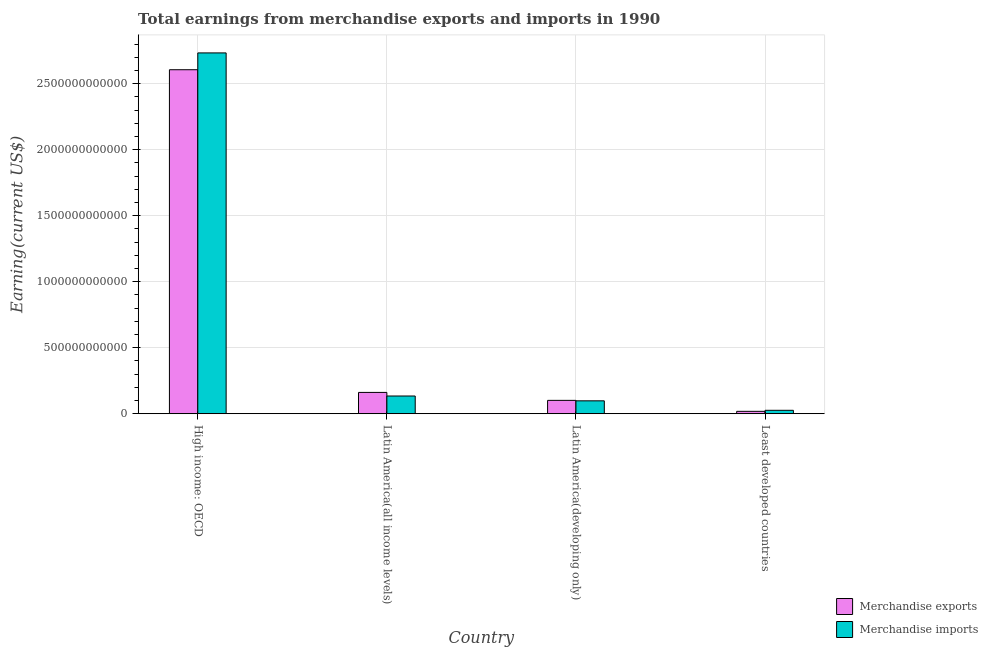How many groups of bars are there?
Make the answer very short. 4. Are the number of bars on each tick of the X-axis equal?
Make the answer very short. Yes. How many bars are there on the 2nd tick from the left?
Provide a succinct answer. 2. How many bars are there on the 4th tick from the right?
Provide a short and direct response. 2. What is the label of the 4th group of bars from the left?
Ensure brevity in your answer.  Least developed countries. What is the earnings from merchandise exports in Latin America(all income levels)?
Make the answer very short. 1.61e+11. Across all countries, what is the maximum earnings from merchandise imports?
Your response must be concise. 2.73e+12. Across all countries, what is the minimum earnings from merchandise imports?
Make the answer very short. 2.60e+1. In which country was the earnings from merchandise exports maximum?
Ensure brevity in your answer.  High income: OECD. In which country was the earnings from merchandise exports minimum?
Offer a very short reply. Least developed countries. What is the total earnings from merchandise exports in the graph?
Give a very brief answer. 2.89e+12. What is the difference between the earnings from merchandise exports in Latin America(developing only) and that in Least developed countries?
Keep it short and to the point. 8.30e+1. What is the difference between the earnings from merchandise imports in Latin America(all income levels) and the earnings from merchandise exports in High income: OECD?
Make the answer very short. -2.47e+12. What is the average earnings from merchandise exports per country?
Keep it short and to the point. 7.22e+11. What is the difference between the earnings from merchandise exports and earnings from merchandise imports in Latin America(developing only)?
Ensure brevity in your answer.  3.56e+09. In how many countries, is the earnings from merchandise exports greater than 2000000000000 US$?
Make the answer very short. 1. What is the ratio of the earnings from merchandise exports in Latin America(developing only) to that in Least developed countries?
Your response must be concise. 5.55. Is the earnings from merchandise imports in Latin America(all income levels) less than that in Least developed countries?
Make the answer very short. No. Is the difference between the earnings from merchandise exports in Latin America(all income levels) and Least developed countries greater than the difference between the earnings from merchandise imports in Latin America(all income levels) and Least developed countries?
Ensure brevity in your answer.  Yes. What is the difference between the highest and the second highest earnings from merchandise imports?
Give a very brief answer. 2.60e+12. What is the difference between the highest and the lowest earnings from merchandise exports?
Offer a terse response. 2.59e+12. What does the 2nd bar from the left in High income: OECD represents?
Make the answer very short. Merchandise imports. How many bars are there?
Keep it short and to the point. 8. What is the difference between two consecutive major ticks on the Y-axis?
Give a very brief answer. 5.00e+11. Are the values on the major ticks of Y-axis written in scientific E-notation?
Keep it short and to the point. No. Where does the legend appear in the graph?
Your answer should be very brief. Bottom right. How many legend labels are there?
Your answer should be very brief. 2. What is the title of the graph?
Provide a succinct answer. Total earnings from merchandise exports and imports in 1990. Does "Secondary school" appear as one of the legend labels in the graph?
Your response must be concise. No. What is the label or title of the Y-axis?
Your response must be concise. Earning(current US$). What is the Earning(current US$) in Merchandise exports in High income: OECD?
Your response must be concise. 2.61e+12. What is the Earning(current US$) of Merchandise imports in High income: OECD?
Keep it short and to the point. 2.73e+12. What is the Earning(current US$) of Merchandise exports in Latin America(all income levels)?
Your response must be concise. 1.61e+11. What is the Earning(current US$) of Merchandise imports in Latin America(all income levels)?
Give a very brief answer. 1.34e+11. What is the Earning(current US$) in Merchandise exports in Latin America(developing only)?
Make the answer very short. 1.01e+11. What is the Earning(current US$) of Merchandise imports in Latin America(developing only)?
Offer a very short reply. 9.77e+1. What is the Earning(current US$) of Merchandise exports in Least developed countries?
Ensure brevity in your answer.  1.82e+1. What is the Earning(current US$) of Merchandise imports in Least developed countries?
Your answer should be very brief. 2.60e+1. Across all countries, what is the maximum Earning(current US$) of Merchandise exports?
Offer a terse response. 2.61e+12. Across all countries, what is the maximum Earning(current US$) in Merchandise imports?
Keep it short and to the point. 2.73e+12. Across all countries, what is the minimum Earning(current US$) in Merchandise exports?
Your response must be concise. 1.82e+1. Across all countries, what is the minimum Earning(current US$) in Merchandise imports?
Provide a short and direct response. 2.60e+1. What is the total Earning(current US$) in Merchandise exports in the graph?
Your answer should be compact. 2.89e+12. What is the total Earning(current US$) in Merchandise imports in the graph?
Provide a succinct answer. 2.99e+12. What is the difference between the Earning(current US$) in Merchandise exports in High income: OECD and that in Latin America(all income levels)?
Offer a terse response. 2.44e+12. What is the difference between the Earning(current US$) of Merchandise imports in High income: OECD and that in Latin America(all income levels)?
Keep it short and to the point. 2.60e+12. What is the difference between the Earning(current US$) in Merchandise exports in High income: OECD and that in Latin America(developing only)?
Provide a short and direct response. 2.50e+12. What is the difference between the Earning(current US$) of Merchandise imports in High income: OECD and that in Latin America(developing only)?
Your answer should be very brief. 2.64e+12. What is the difference between the Earning(current US$) of Merchandise exports in High income: OECD and that in Least developed countries?
Give a very brief answer. 2.59e+12. What is the difference between the Earning(current US$) of Merchandise imports in High income: OECD and that in Least developed countries?
Provide a succinct answer. 2.71e+12. What is the difference between the Earning(current US$) of Merchandise exports in Latin America(all income levels) and that in Latin America(developing only)?
Your answer should be very brief. 6.02e+1. What is the difference between the Earning(current US$) in Merchandise imports in Latin America(all income levels) and that in Latin America(developing only)?
Keep it short and to the point. 3.65e+1. What is the difference between the Earning(current US$) of Merchandise exports in Latin America(all income levels) and that in Least developed countries?
Make the answer very short. 1.43e+11. What is the difference between the Earning(current US$) of Merchandise imports in Latin America(all income levels) and that in Least developed countries?
Provide a short and direct response. 1.08e+11. What is the difference between the Earning(current US$) in Merchandise exports in Latin America(developing only) and that in Least developed countries?
Your answer should be compact. 8.30e+1. What is the difference between the Earning(current US$) in Merchandise imports in Latin America(developing only) and that in Least developed countries?
Your answer should be compact. 7.17e+1. What is the difference between the Earning(current US$) in Merchandise exports in High income: OECD and the Earning(current US$) in Merchandise imports in Latin America(all income levels)?
Provide a succinct answer. 2.47e+12. What is the difference between the Earning(current US$) of Merchandise exports in High income: OECD and the Earning(current US$) of Merchandise imports in Latin America(developing only)?
Keep it short and to the point. 2.51e+12. What is the difference between the Earning(current US$) of Merchandise exports in High income: OECD and the Earning(current US$) of Merchandise imports in Least developed countries?
Make the answer very short. 2.58e+12. What is the difference between the Earning(current US$) of Merchandise exports in Latin America(all income levels) and the Earning(current US$) of Merchandise imports in Latin America(developing only)?
Give a very brief answer. 6.38e+1. What is the difference between the Earning(current US$) of Merchandise exports in Latin America(all income levels) and the Earning(current US$) of Merchandise imports in Least developed countries?
Offer a very short reply. 1.35e+11. What is the difference between the Earning(current US$) in Merchandise exports in Latin America(developing only) and the Earning(current US$) in Merchandise imports in Least developed countries?
Your answer should be compact. 7.53e+1. What is the average Earning(current US$) in Merchandise exports per country?
Your response must be concise. 7.22e+11. What is the average Earning(current US$) of Merchandise imports per country?
Provide a succinct answer. 7.48e+11. What is the difference between the Earning(current US$) in Merchandise exports and Earning(current US$) in Merchandise imports in High income: OECD?
Give a very brief answer. -1.27e+11. What is the difference between the Earning(current US$) in Merchandise exports and Earning(current US$) in Merchandise imports in Latin America(all income levels)?
Give a very brief answer. 2.72e+1. What is the difference between the Earning(current US$) in Merchandise exports and Earning(current US$) in Merchandise imports in Latin America(developing only)?
Offer a terse response. 3.56e+09. What is the difference between the Earning(current US$) of Merchandise exports and Earning(current US$) of Merchandise imports in Least developed countries?
Give a very brief answer. -7.77e+09. What is the ratio of the Earning(current US$) in Merchandise exports in High income: OECD to that in Latin America(all income levels)?
Offer a terse response. 16.14. What is the ratio of the Earning(current US$) of Merchandise imports in High income: OECD to that in Latin America(all income levels)?
Your answer should be compact. 20.36. What is the ratio of the Earning(current US$) in Merchandise exports in High income: OECD to that in Latin America(developing only)?
Provide a short and direct response. 25.73. What is the ratio of the Earning(current US$) in Merchandise imports in High income: OECD to that in Latin America(developing only)?
Ensure brevity in your answer.  27.97. What is the ratio of the Earning(current US$) of Merchandise exports in High income: OECD to that in Least developed countries?
Make the answer very short. 142.88. What is the ratio of the Earning(current US$) of Merchandise imports in High income: OECD to that in Least developed countries?
Keep it short and to the point. 105.09. What is the ratio of the Earning(current US$) in Merchandise exports in Latin America(all income levels) to that in Latin America(developing only)?
Provide a short and direct response. 1.59. What is the ratio of the Earning(current US$) of Merchandise imports in Latin America(all income levels) to that in Latin America(developing only)?
Ensure brevity in your answer.  1.37. What is the ratio of the Earning(current US$) of Merchandise exports in Latin America(all income levels) to that in Least developed countries?
Your answer should be very brief. 8.85. What is the ratio of the Earning(current US$) in Merchandise imports in Latin America(all income levels) to that in Least developed countries?
Ensure brevity in your answer.  5.16. What is the ratio of the Earning(current US$) of Merchandise exports in Latin America(developing only) to that in Least developed countries?
Keep it short and to the point. 5.55. What is the ratio of the Earning(current US$) in Merchandise imports in Latin America(developing only) to that in Least developed countries?
Offer a terse response. 3.76. What is the difference between the highest and the second highest Earning(current US$) in Merchandise exports?
Offer a terse response. 2.44e+12. What is the difference between the highest and the second highest Earning(current US$) of Merchandise imports?
Make the answer very short. 2.60e+12. What is the difference between the highest and the lowest Earning(current US$) in Merchandise exports?
Your answer should be very brief. 2.59e+12. What is the difference between the highest and the lowest Earning(current US$) of Merchandise imports?
Offer a terse response. 2.71e+12. 